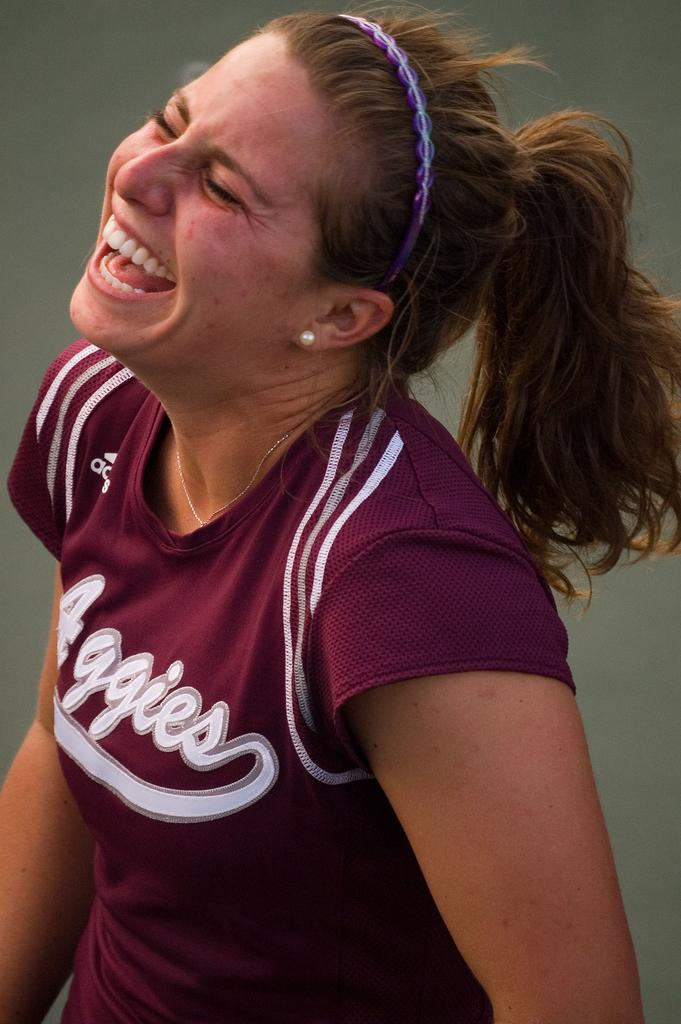<image>
Write a terse but informative summary of the picture. Laughing woman wearing a maroon colored Aggies athletic shirt. 